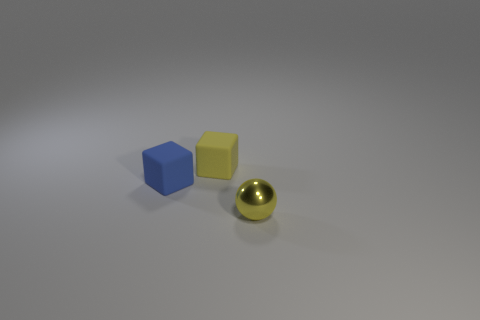Add 1 brown matte balls. How many objects exist? 4 Add 3 small blue rubber objects. How many small blue rubber objects are left? 4 Add 1 purple metal blocks. How many purple metal blocks exist? 1 Subtract all blue cubes. How many cubes are left? 1 Subtract 0 yellow cylinders. How many objects are left? 3 Subtract all blocks. How many objects are left? 1 Subtract 2 cubes. How many cubes are left? 0 Subtract all yellow blocks. Subtract all yellow balls. How many blocks are left? 1 Subtract all blue spheres. How many purple blocks are left? 0 Subtract all tiny blue things. Subtract all yellow metal spheres. How many objects are left? 1 